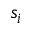Convert formula to latex. <formula><loc_0><loc_0><loc_500><loc_500>s _ { i }</formula> 